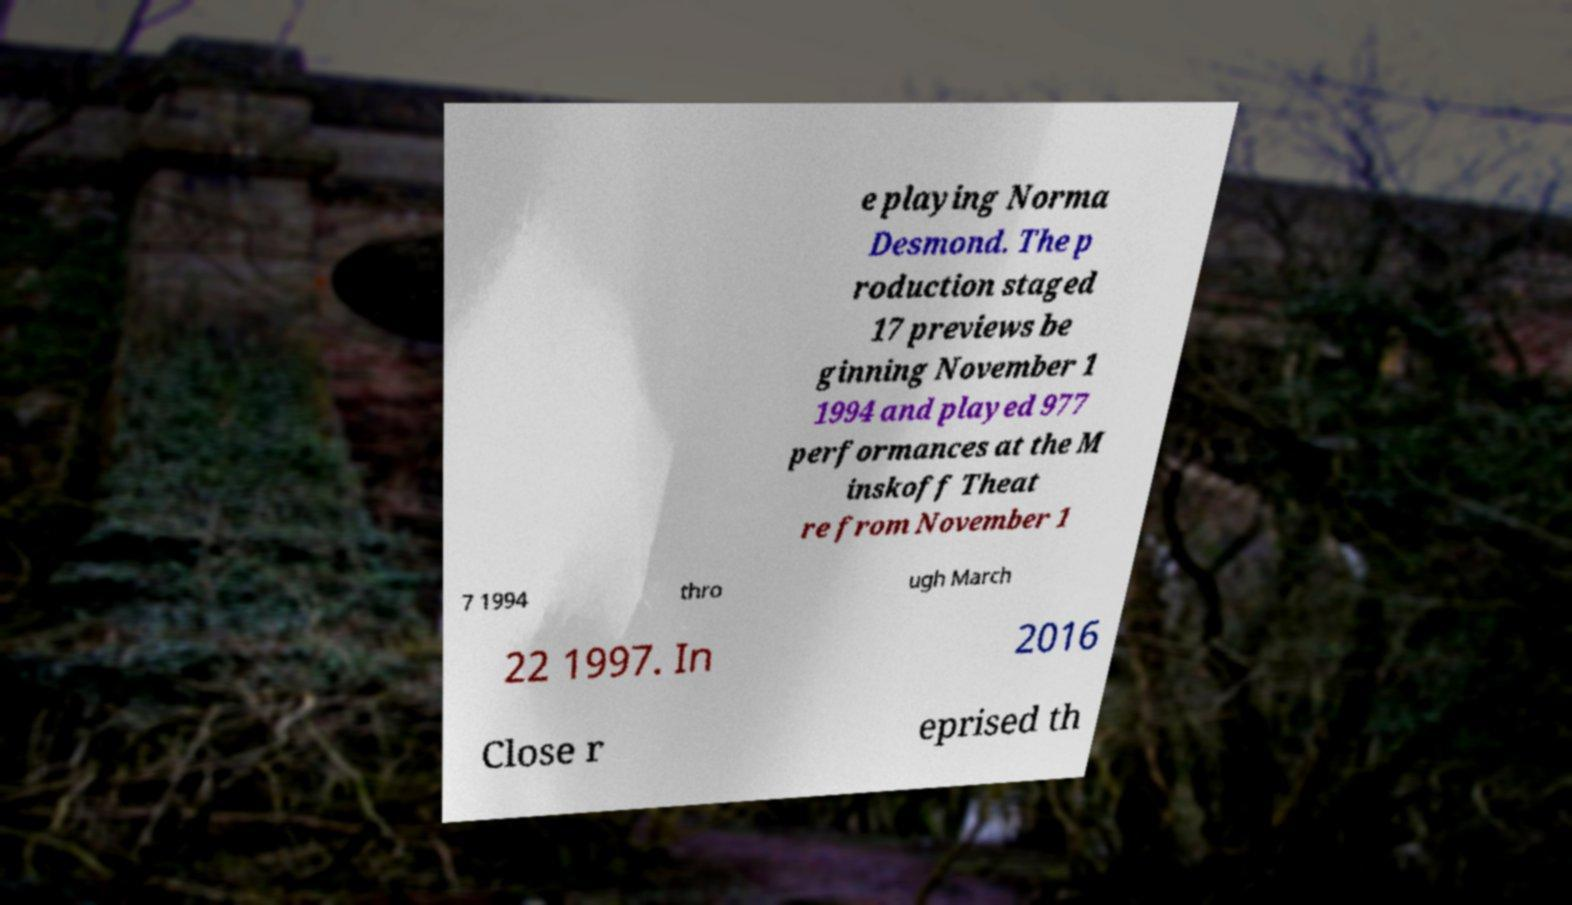Could you assist in decoding the text presented in this image and type it out clearly? e playing Norma Desmond. The p roduction staged 17 previews be ginning November 1 1994 and played 977 performances at the M inskoff Theat re from November 1 7 1994 thro ugh March 22 1997. In 2016 Close r eprised th 